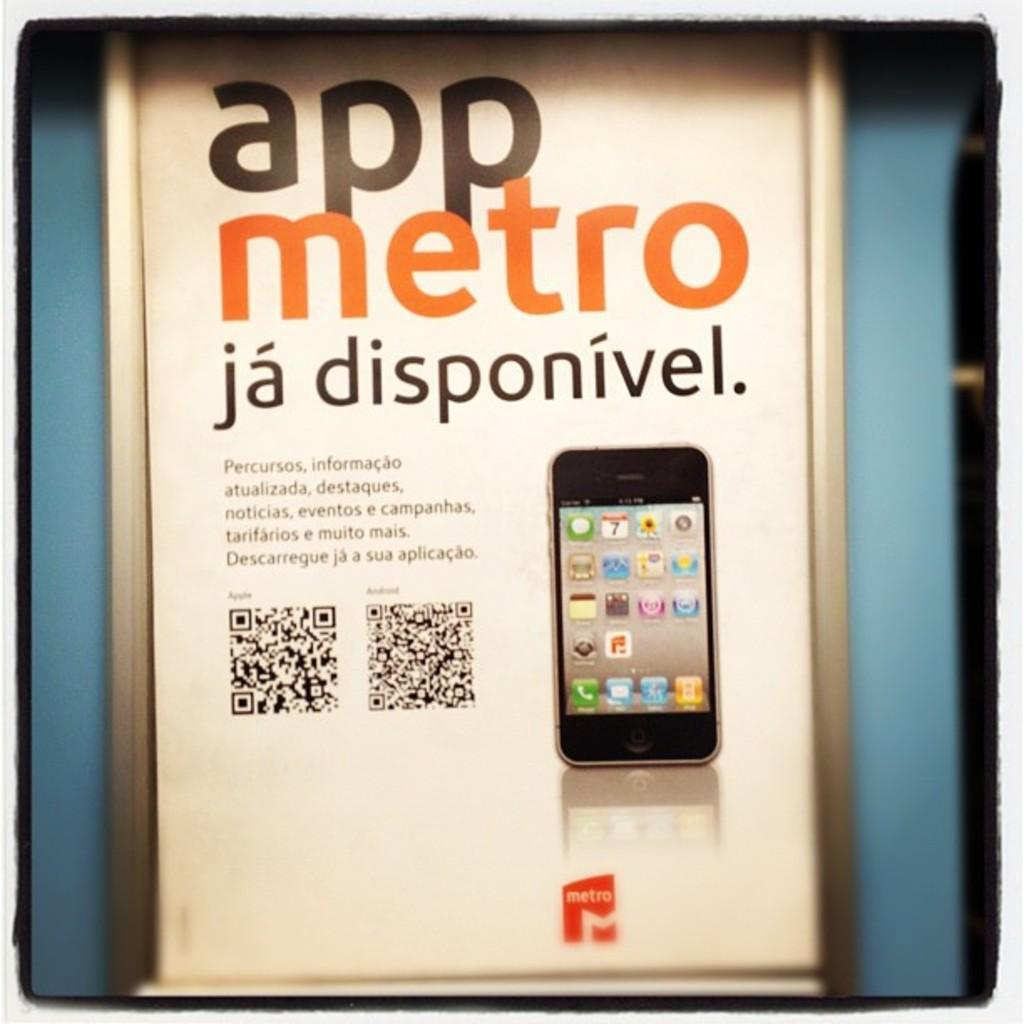<image>
Describe the image concisely. An advertisement for metro is titled "app metro." 